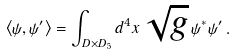Convert formula to latex. <formula><loc_0><loc_0><loc_500><loc_500>\left < \psi , \psi ^ { \prime } \right > = \int _ { D \times D _ { 5 } } d ^ { 4 } x \, \sqrt { g } \, \psi ^ { * } \psi ^ { \prime } \, .</formula> 